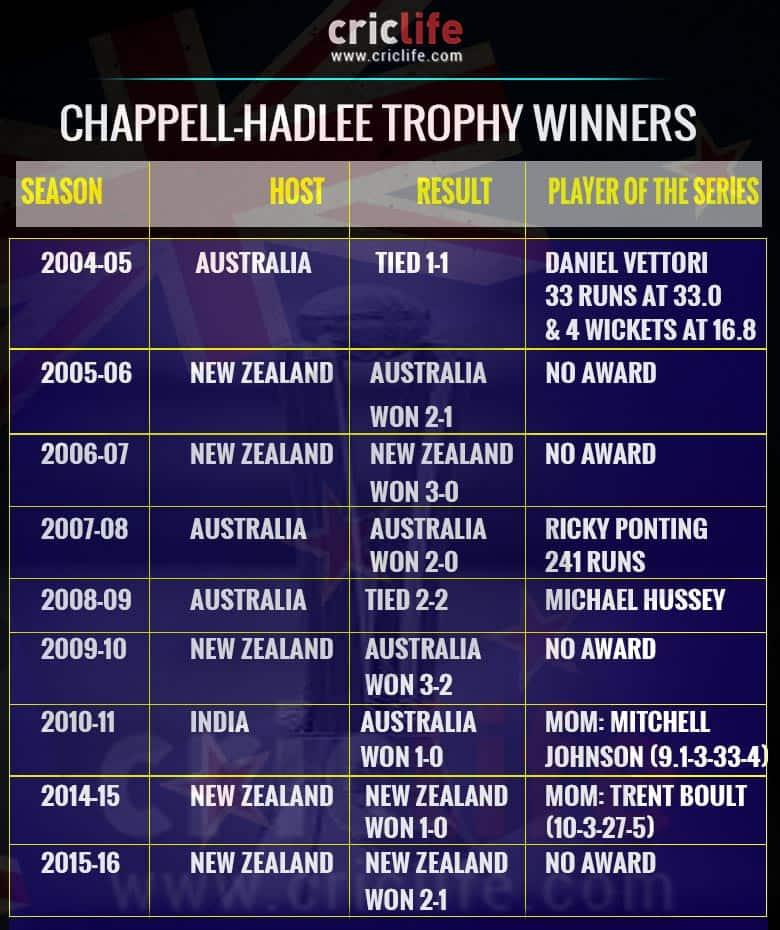Outline some significant characteristics in this image. Australia will host the events three times in total. New Zealand will serve as the host for a total of 5 times. The title player of the series has not received any awards for the past 4 years. 